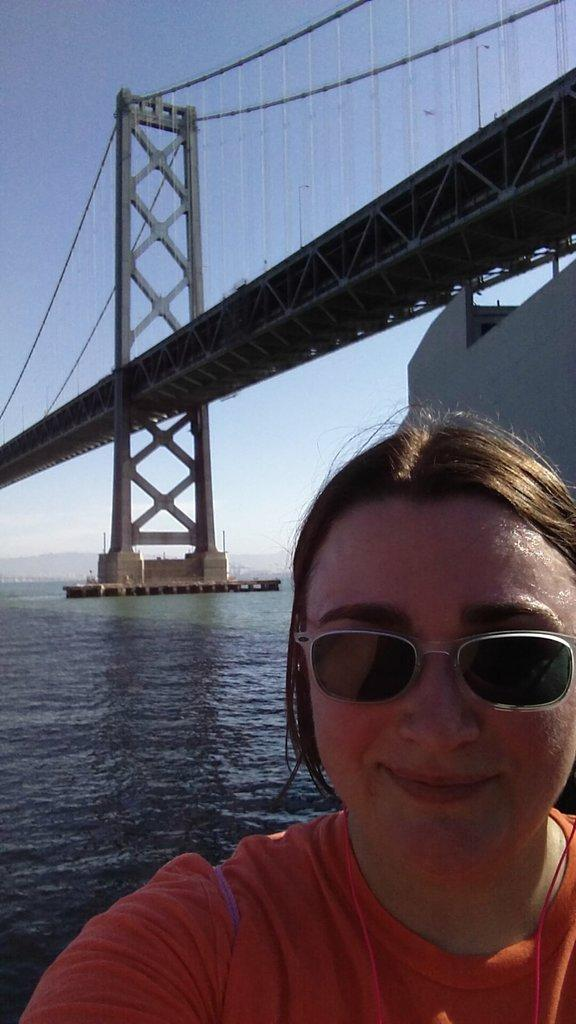Who is present in the image? There is a person in the image. What accessory is the person wearing? The person is wearing glasses. What type of structure can be seen in the image? There is a bridge in the image. What natural element is visible in the image? There is water visible in the image. What part of the environment is visible in the image? The sky is visible in the image. Where are the fairies hiding in the image? There are no fairies present in the image. What type of camera is being used to take the picture? The facts provided do not mention a camera, so it cannot be determined from the image. 